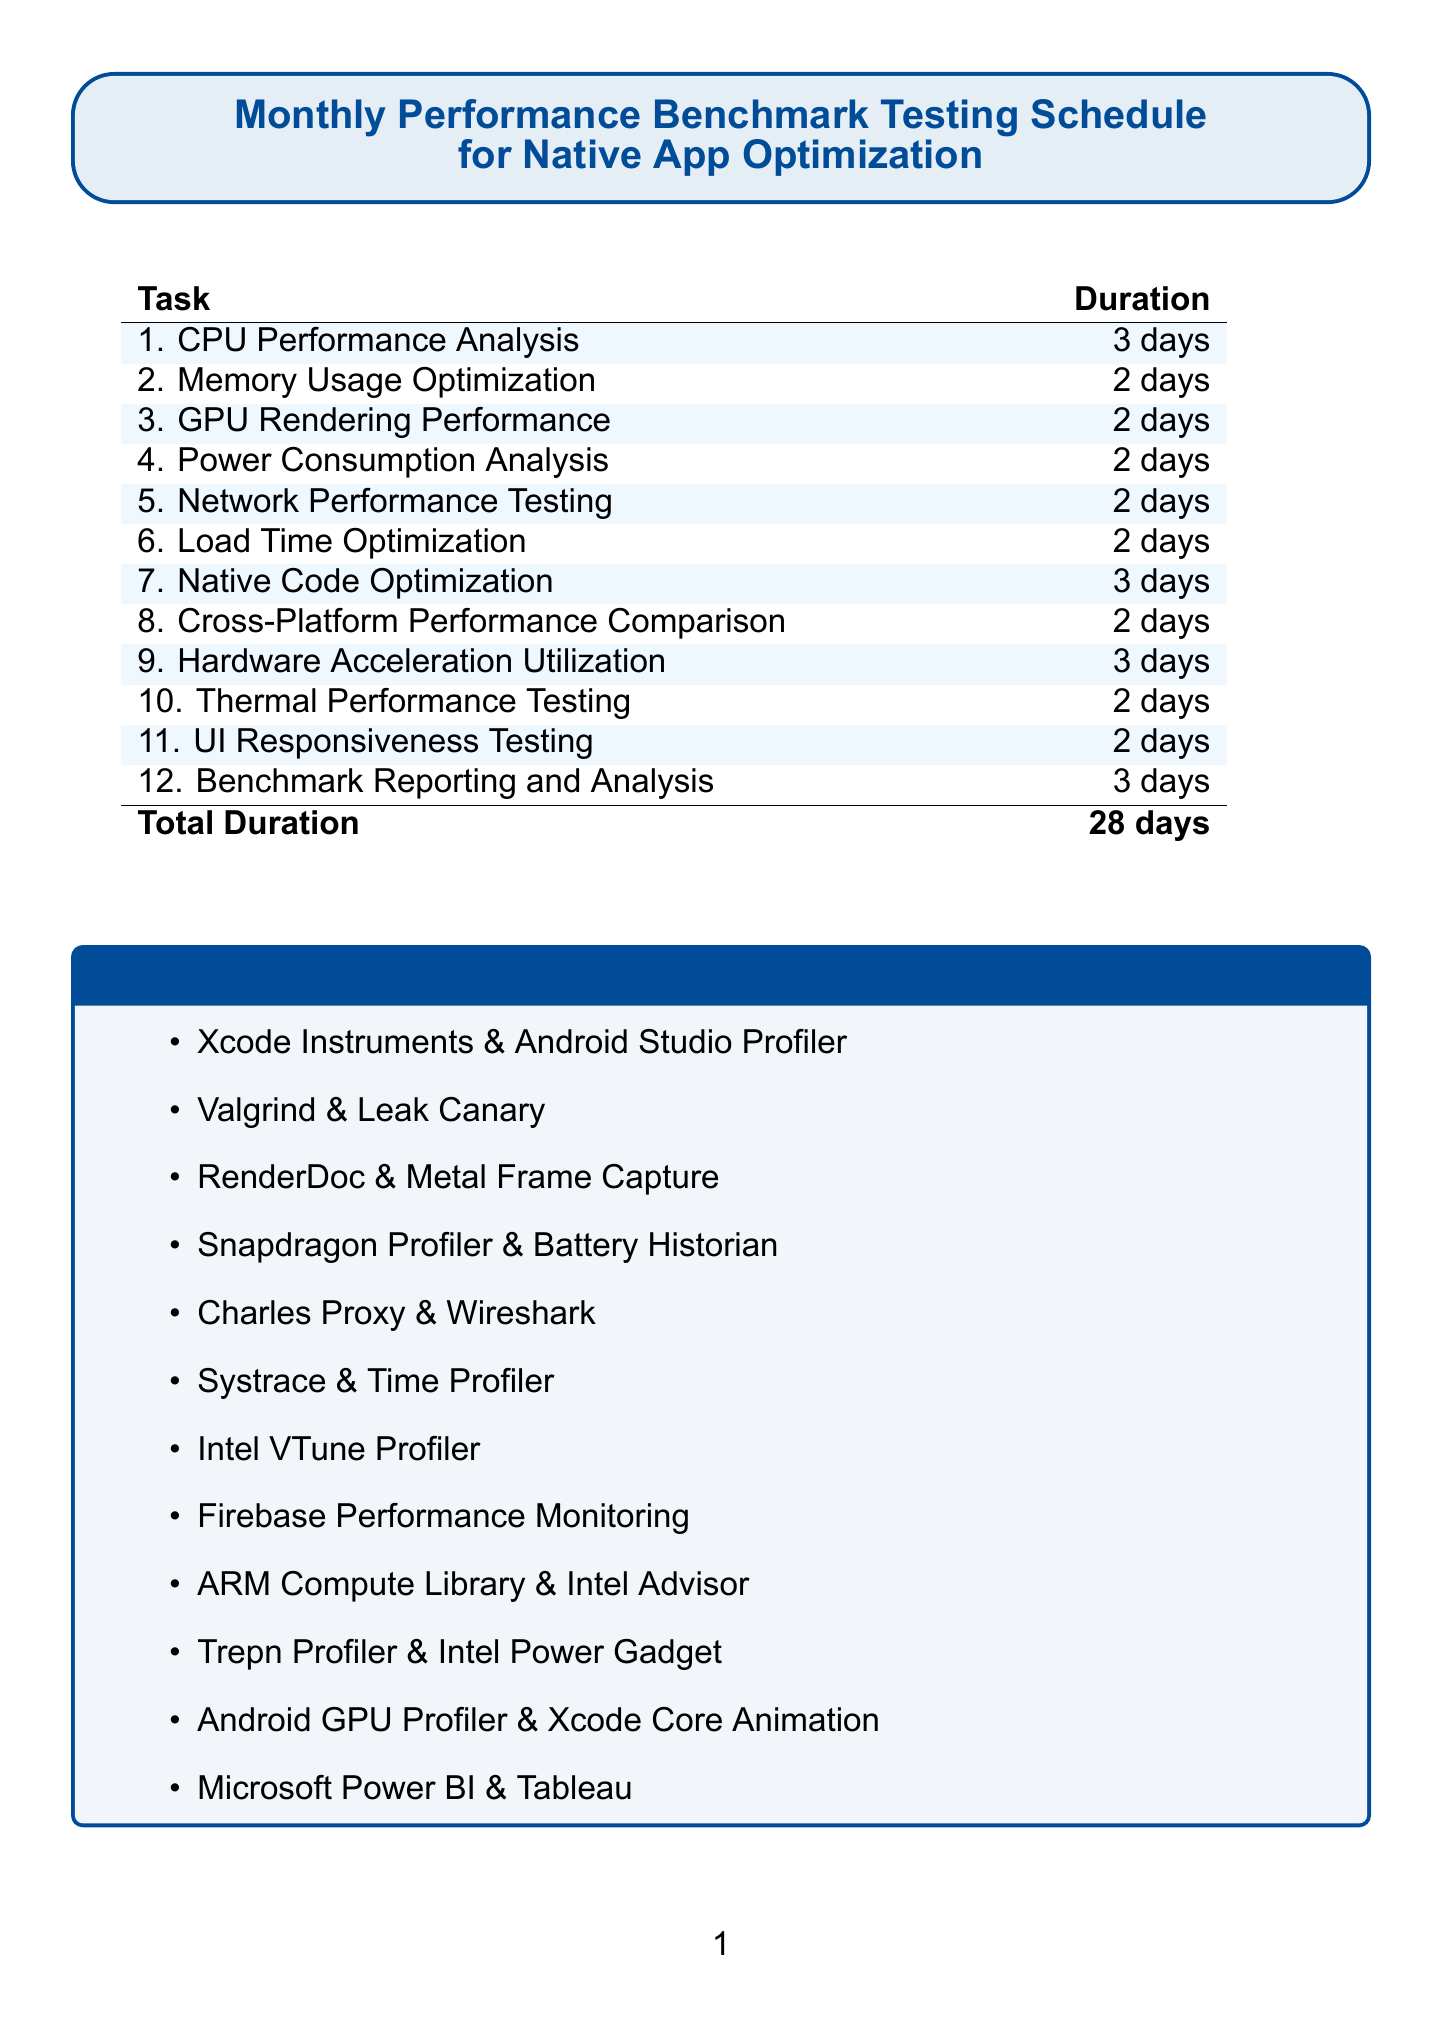What is the total duration of the benchmark tasks? The total duration is calculated from the sum of the days allocated for each task in the document, which adds up to 28 days.
Answer: 28 days Which task focuses on measuring CPU performance? The task specifically aimed at this is labeled CPU Performance Analysis in the document.
Answer: CPU Performance Analysis How many tools are used for memory usage optimization? The document specifies that two tools are used for this task: Valgrind and Leak Canary.
Answer: 2 What is the duration for the Native Code Optimization task? The document clearly states that the duration for Native Code Optimization is 3 days.
Answer: 3 days Which task has the shortest duration? Among the tasks listed, the Memory Usage Optimization, GPU Rendering Performance, Power Consumption Analysis, Network Performance Testing, Load Time Optimization, Cross-Platform Performance Comparison, Thermal Performance Testing, and UI Responsiveness Testing each have a duration of 2 days, the shortest duration.
Answer: 2 days What should be compiled during the Benchmark Reporting and Analysis task? This task involves compiling benchmark results and comparing them with previous months.
Answer: Benchmark results How many total tasks are listed in the document? The document enumerates a total of 12 tasks focused on different aspects of performance optimization.
Answer: 12 Which performance analysis tool is used for power consumption? The document indicates that the tools used for power consumption analysis are Snapdragon Profiler and Battery Historian.
Answer: Snapdragon Profiler and Battery Historian What is the primary purpose of this schedule? The primary purpose of the schedule is to outline tasks for optimizing software-hardware integration in native apps.
Answer: Optimizing software-hardware integration 